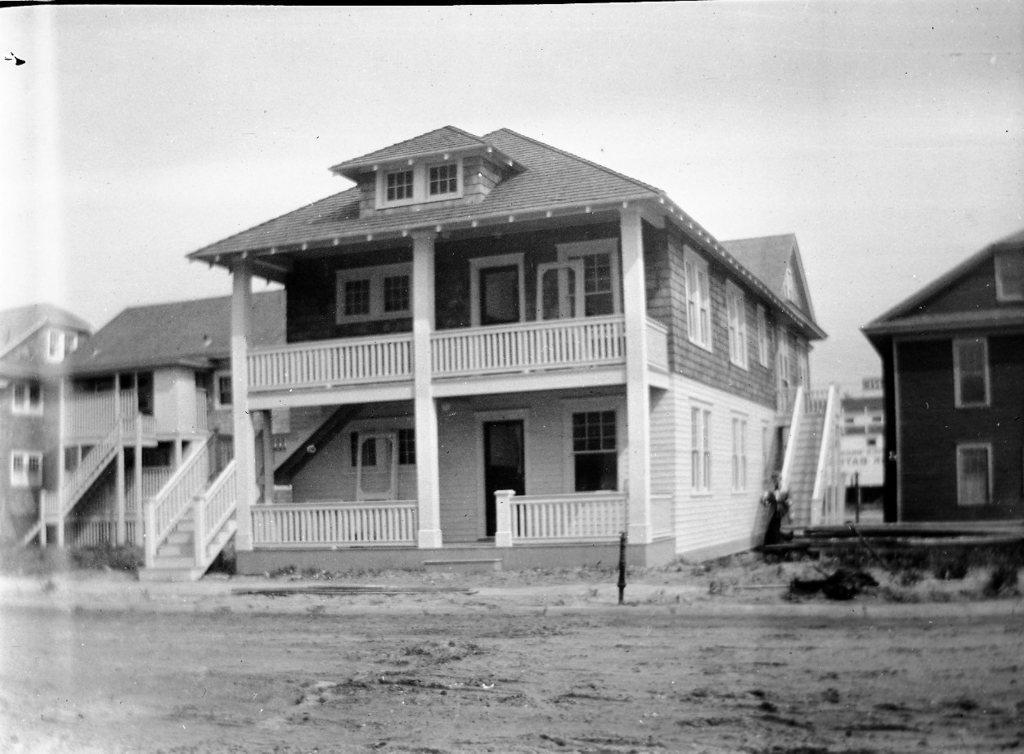Describe this image in one or two sentences. As we can see in the image there are buildings, stairs, fence, doors and windows. At the top there is a sky. 